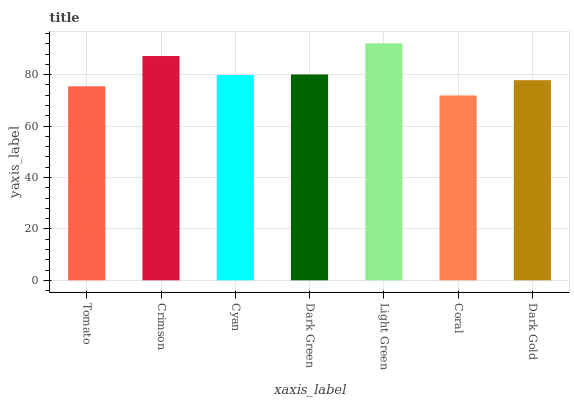Is Coral the minimum?
Answer yes or no. Yes. Is Light Green the maximum?
Answer yes or no. Yes. Is Crimson the minimum?
Answer yes or no. No. Is Crimson the maximum?
Answer yes or no. No. Is Crimson greater than Tomato?
Answer yes or no. Yes. Is Tomato less than Crimson?
Answer yes or no. Yes. Is Tomato greater than Crimson?
Answer yes or no. No. Is Crimson less than Tomato?
Answer yes or no. No. Is Cyan the high median?
Answer yes or no. Yes. Is Cyan the low median?
Answer yes or no. Yes. Is Tomato the high median?
Answer yes or no. No. Is Coral the low median?
Answer yes or no. No. 